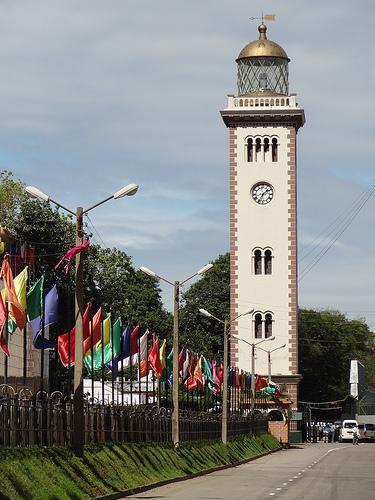How many towers are there?
Give a very brief answer. 1. 